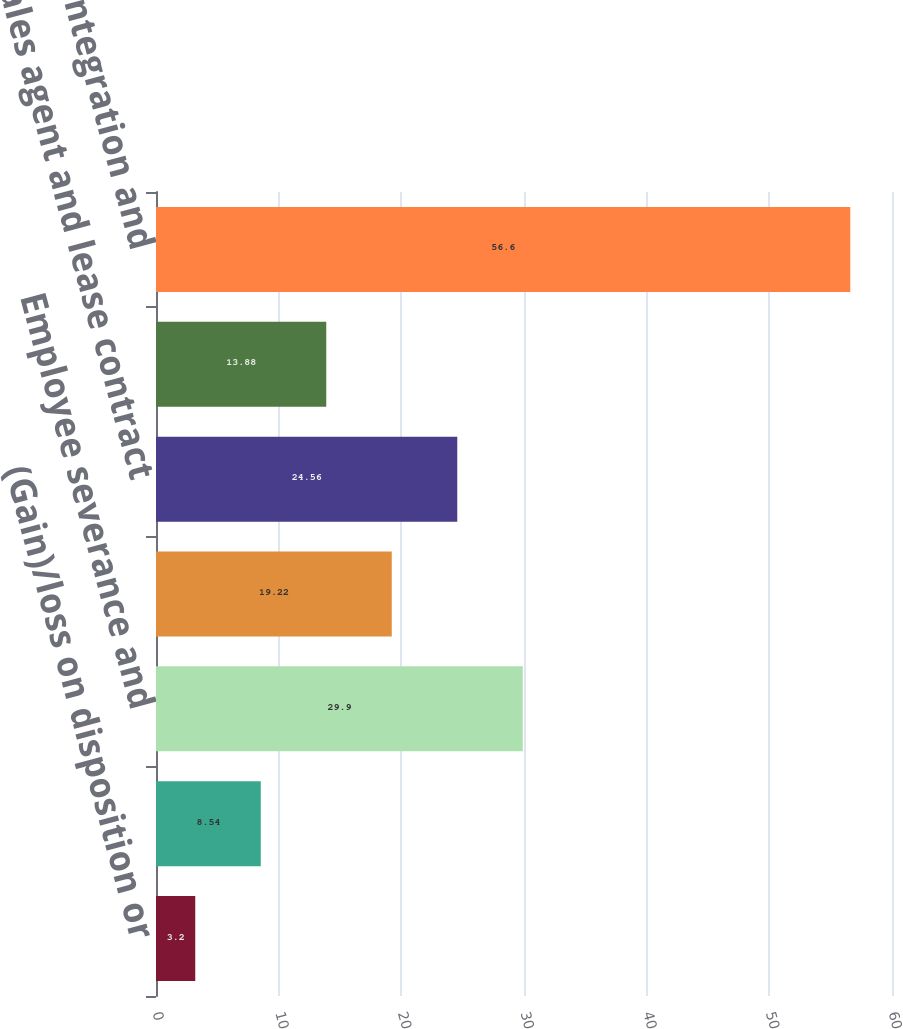<chart> <loc_0><loc_0><loc_500><loc_500><bar_chart><fcel>(Gain)/loss on disposition or<fcel>Consulting and professional<fcel>Employee severance and<fcel>Information technology<fcel>Sales agent and lease contract<fcel>Other<fcel>Acquisition integration and<nl><fcel>3.2<fcel>8.54<fcel>29.9<fcel>19.22<fcel>24.56<fcel>13.88<fcel>56.6<nl></chart> 